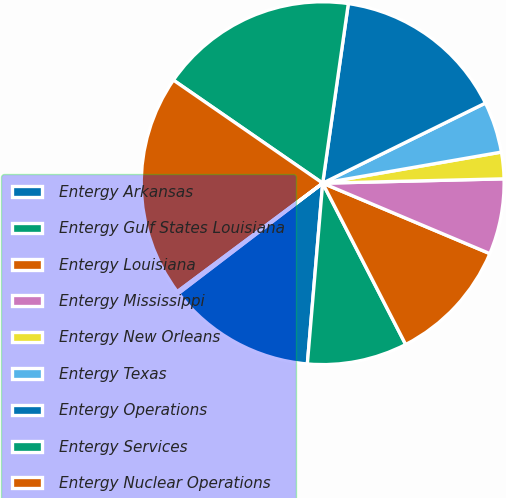<chart> <loc_0><loc_0><loc_500><loc_500><pie_chart><fcel>Entergy Arkansas<fcel>Entergy Gulf States Louisiana<fcel>Entergy Louisiana<fcel>Entergy Mississippi<fcel>Entergy New Orleans<fcel>Entergy Texas<fcel>Entergy Operations<fcel>Entergy Services<fcel>Entergy Nuclear Operations<fcel>Other subsidiaries<nl><fcel>13.27%<fcel>8.91%<fcel>11.09%<fcel>6.73%<fcel>2.36%<fcel>4.54%<fcel>15.46%<fcel>17.64%<fcel>19.82%<fcel>0.18%<nl></chart> 